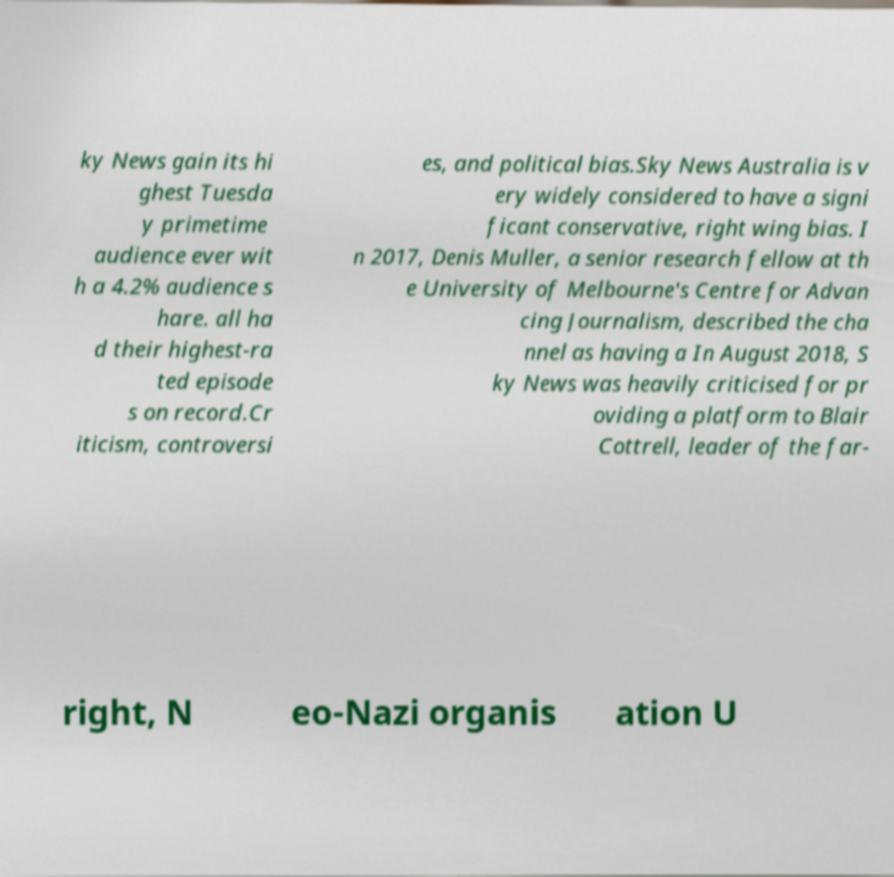Can you read and provide the text displayed in the image?This photo seems to have some interesting text. Can you extract and type it out for me? ky News gain its hi ghest Tuesda y primetime audience ever wit h a 4.2% audience s hare. all ha d their highest-ra ted episode s on record.Cr iticism, controversi es, and political bias.Sky News Australia is v ery widely considered to have a signi ficant conservative, right wing bias. I n 2017, Denis Muller, a senior research fellow at th e University of Melbourne's Centre for Advan cing Journalism, described the cha nnel as having a In August 2018, S ky News was heavily criticised for pr oviding a platform to Blair Cottrell, leader of the far- right, N eo-Nazi organis ation U 